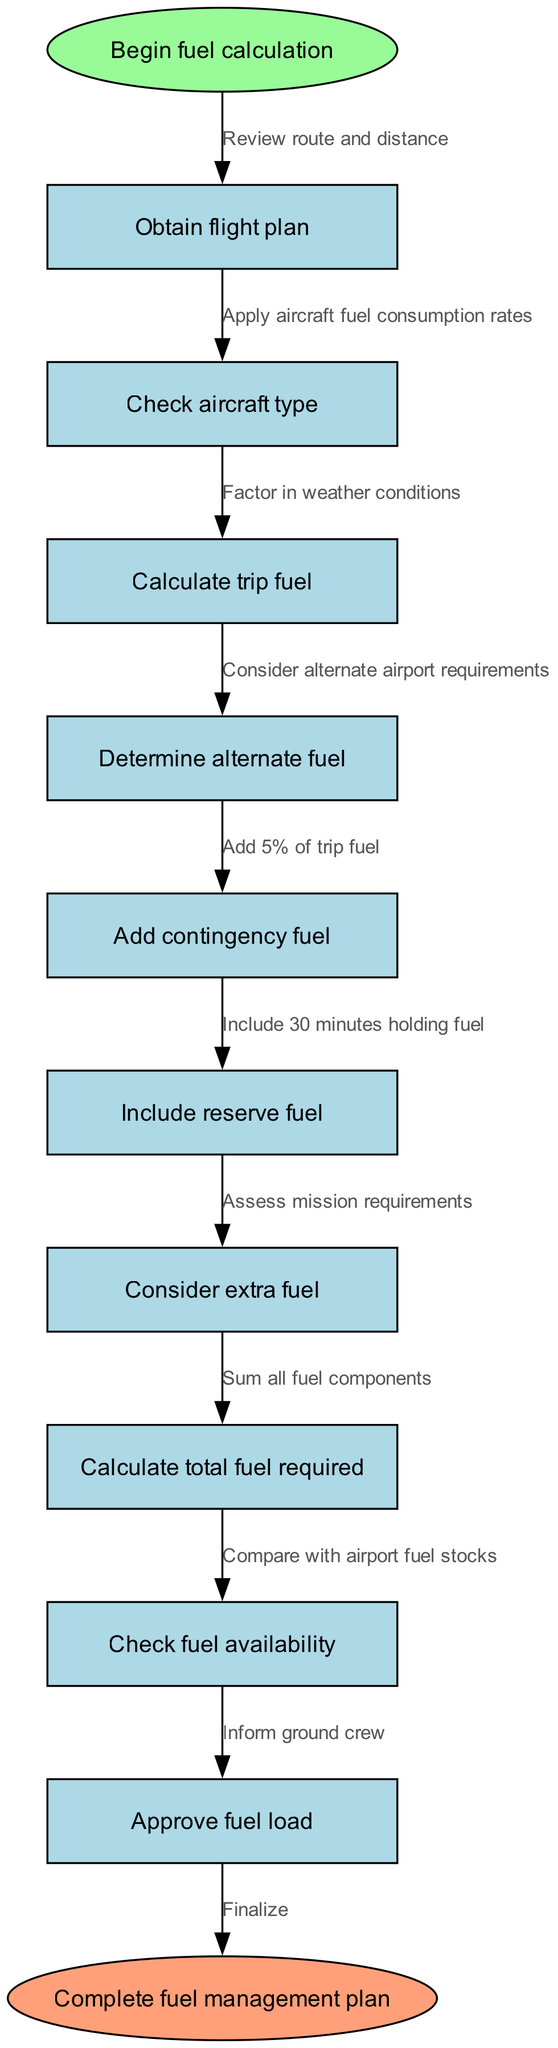What is the starting point of the fuel calculation workflow? The diagram indicates that the starting point is labeled as "Begin fuel calculation" in an ellipse shape.
Answer: Begin fuel calculation How many nodes are present in the workflow diagram? The diagram consists of a total of 10 nodes, excluding the start and end nodes. The count includes all steps listed in the nodes section.
Answer: 10 What is the last action before finalizing the fuel management plan? According to the diagram, the last action before finalizing is "Approve fuel load," which is the last node before the end node.
Answer: Approve fuel load Which node follows the "Calculate trip fuel" node? The flow sequence indicates that the node following "Calculate trip fuel" is "Determine alternate fuel," as there is a direct connection from the former to the latter in the diagram.
Answer: Determine alternate fuel What component is added to the trip fuel calculation as contingency fuel? The diagram specifies that an additional 5% of trip fuel is added for contingency fuel, which is part of the overall fuel calculation process.
Answer: 5% What is the relationship between "Check fuel availability" and "Approve fuel load"? The diagram shows that "Check fuel availability" is directly connected to "Approve fuel load," indicating that the approval of the fuel load can only occur after checking the availability.
Answer: Direct connection What action is taken after assessing mission requirements? The next action after assessing mission requirements is to sum all fuel components, indicating a sequential flow in the diagram from assessing to calculating total fuel.
Answer: Sum all fuel components How does the workflow consider weather conditions? The diagram indicates that weather conditions are factored in during the trip fuel calculation, suggesting that this step plays a role in determining fuel needs.
Answer: Factor in weather conditions What is the end result of the fuel management workflow? The workflow culminates with the final action labeled "Complete fuel management plan," which signifies that all preceding steps lead to this conclusive outcome.
Answer: Complete fuel management plan 